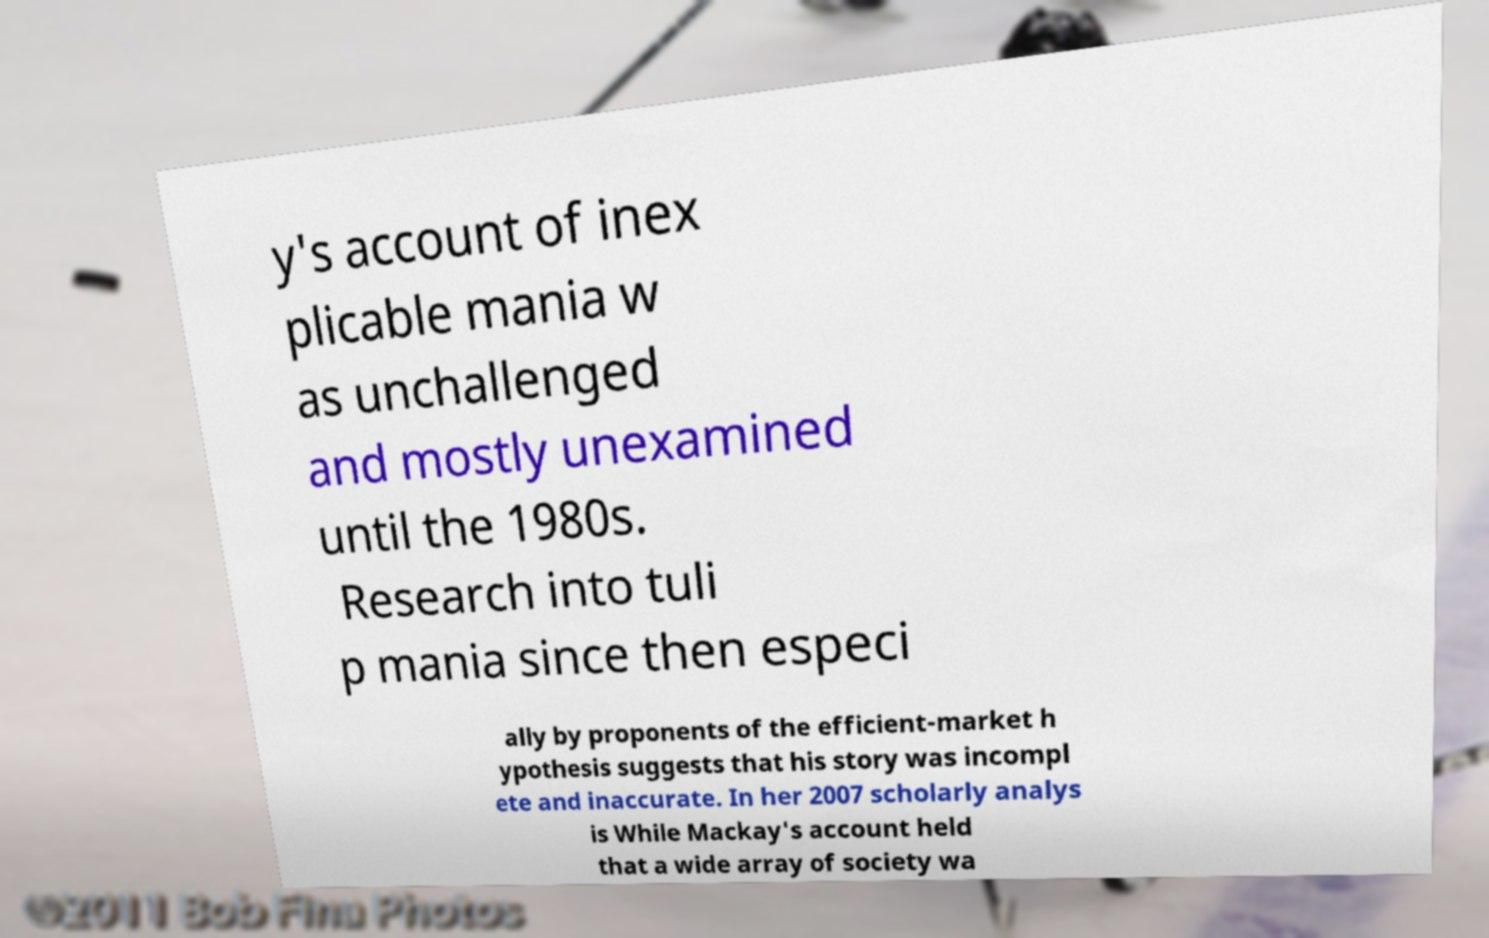Please read and relay the text visible in this image. What does it say? y's account of inex plicable mania w as unchallenged and mostly unexamined until the 1980s. Research into tuli p mania since then especi ally by proponents of the efficient-market h ypothesis suggests that his story was incompl ete and inaccurate. In her 2007 scholarly analys is While Mackay's account held that a wide array of society wa 